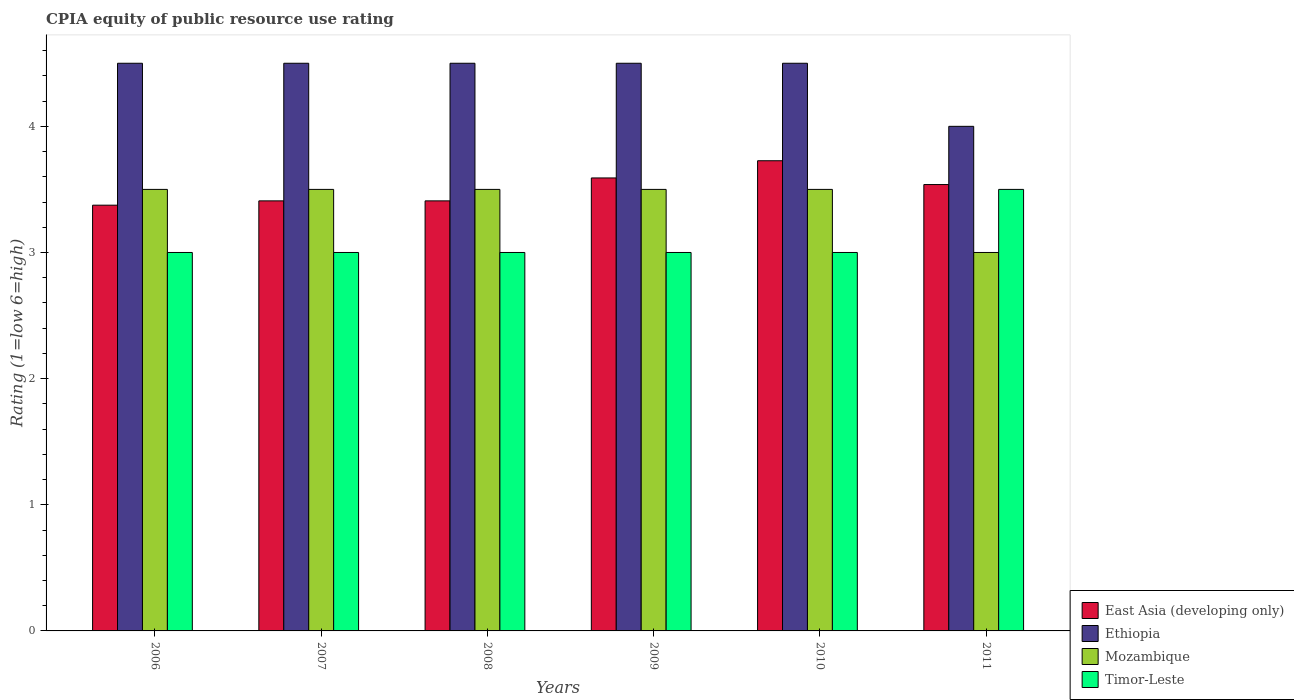How many bars are there on the 5th tick from the left?
Keep it short and to the point. 4. What is the CPIA rating in Mozambique in 2010?
Make the answer very short. 3.5. Across all years, what is the maximum CPIA rating in Ethiopia?
Your answer should be compact. 4.5. In which year was the CPIA rating in Mozambique maximum?
Ensure brevity in your answer.  2006. In which year was the CPIA rating in Mozambique minimum?
Ensure brevity in your answer.  2011. What is the total CPIA rating in East Asia (developing only) in the graph?
Keep it short and to the point. 21.05. What is the difference between the CPIA rating in East Asia (developing only) in 2010 and that in 2011?
Keep it short and to the point. 0.19. What is the average CPIA rating in Ethiopia per year?
Provide a succinct answer. 4.42. In the year 2011, what is the difference between the CPIA rating in East Asia (developing only) and CPIA rating in Timor-Leste?
Ensure brevity in your answer.  0.04. In how many years, is the CPIA rating in Mozambique greater than 2.4?
Provide a short and direct response. 6. Is the CPIA rating in Timor-Leste in 2007 less than that in 2011?
Keep it short and to the point. Yes. Is the difference between the CPIA rating in East Asia (developing only) in 2008 and 2011 greater than the difference between the CPIA rating in Timor-Leste in 2008 and 2011?
Your response must be concise. Yes. What is the difference between the highest and the lowest CPIA rating in Ethiopia?
Give a very brief answer. 0.5. In how many years, is the CPIA rating in Timor-Leste greater than the average CPIA rating in Timor-Leste taken over all years?
Your answer should be very brief. 1. Is the sum of the CPIA rating in Ethiopia in 2007 and 2008 greater than the maximum CPIA rating in Timor-Leste across all years?
Offer a terse response. Yes. Is it the case that in every year, the sum of the CPIA rating in East Asia (developing only) and CPIA rating in Ethiopia is greater than the sum of CPIA rating in Timor-Leste and CPIA rating in Mozambique?
Offer a terse response. Yes. What does the 4th bar from the left in 2011 represents?
Ensure brevity in your answer.  Timor-Leste. What does the 3rd bar from the right in 2011 represents?
Offer a terse response. Ethiopia. Is it the case that in every year, the sum of the CPIA rating in Ethiopia and CPIA rating in Mozambique is greater than the CPIA rating in Timor-Leste?
Provide a succinct answer. Yes. Are all the bars in the graph horizontal?
Your response must be concise. No. What is the difference between two consecutive major ticks on the Y-axis?
Your answer should be compact. 1. Does the graph contain grids?
Give a very brief answer. No. Where does the legend appear in the graph?
Offer a very short reply. Bottom right. How are the legend labels stacked?
Your answer should be compact. Vertical. What is the title of the graph?
Your answer should be very brief. CPIA equity of public resource use rating. What is the label or title of the X-axis?
Give a very brief answer. Years. What is the label or title of the Y-axis?
Provide a short and direct response. Rating (1=low 6=high). What is the Rating (1=low 6=high) of East Asia (developing only) in 2006?
Your response must be concise. 3.38. What is the Rating (1=low 6=high) of Ethiopia in 2006?
Provide a succinct answer. 4.5. What is the Rating (1=low 6=high) of Mozambique in 2006?
Your answer should be very brief. 3.5. What is the Rating (1=low 6=high) of East Asia (developing only) in 2007?
Ensure brevity in your answer.  3.41. What is the Rating (1=low 6=high) in Mozambique in 2007?
Offer a terse response. 3.5. What is the Rating (1=low 6=high) in East Asia (developing only) in 2008?
Provide a short and direct response. 3.41. What is the Rating (1=low 6=high) in Ethiopia in 2008?
Your answer should be very brief. 4.5. What is the Rating (1=low 6=high) of East Asia (developing only) in 2009?
Offer a terse response. 3.59. What is the Rating (1=low 6=high) of East Asia (developing only) in 2010?
Ensure brevity in your answer.  3.73. What is the Rating (1=low 6=high) in Mozambique in 2010?
Make the answer very short. 3.5. What is the Rating (1=low 6=high) of East Asia (developing only) in 2011?
Make the answer very short. 3.54. What is the Rating (1=low 6=high) of Timor-Leste in 2011?
Offer a terse response. 3.5. Across all years, what is the maximum Rating (1=low 6=high) in East Asia (developing only)?
Your answer should be compact. 3.73. Across all years, what is the minimum Rating (1=low 6=high) in East Asia (developing only)?
Your answer should be very brief. 3.38. Across all years, what is the minimum Rating (1=low 6=high) of Mozambique?
Provide a succinct answer. 3. Across all years, what is the minimum Rating (1=low 6=high) of Timor-Leste?
Give a very brief answer. 3. What is the total Rating (1=low 6=high) of East Asia (developing only) in the graph?
Offer a terse response. 21.05. What is the total Rating (1=low 6=high) of Timor-Leste in the graph?
Offer a terse response. 18.5. What is the difference between the Rating (1=low 6=high) in East Asia (developing only) in 2006 and that in 2007?
Offer a terse response. -0.03. What is the difference between the Rating (1=low 6=high) in Timor-Leste in 2006 and that in 2007?
Your answer should be very brief. 0. What is the difference between the Rating (1=low 6=high) of East Asia (developing only) in 2006 and that in 2008?
Provide a short and direct response. -0.03. What is the difference between the Rating (1=low 6=high) in Ethiopia in 2006 and that in 2008?
Your answer should be compact. 0. What is the difference between the Rating (1=low 6=high) of Mozambique in 2006 and that in 2008?
Your answer should be compact. 0. What is the difference between the Rating (1=low 6=high) in East Asia (developing only) in 2006 and that in 2009?
Give a very brief answer. -0.22. What is the difference between the Rating (1=low 6=high) in Ethiopia in 2006 and that in 2009?
Offer a terse response. 0. What is the difference between the Rating (1=low 6=high) of East Asia (developing only) in 2006 and that in 2010?
Make the answer very short. -0.35. What is the difference between the Rating (1=low 6=high) in Mozambique in 2006 and that in 2010?
Your response must be concise. 0. What is the difference between the Rating (1=low 6=high) of East Asia (developing only) in 2006 and that in 2011?
Make the answer very short. -0.16. What is the difference between the Rating (1=low 6=high) of Timor-Leste in 2006 and that in 2011?
Offer a terse response. -0.5. What is the difference between the Rating (1=low 6=high) in East Asia (developing only) in 2007 and that in 2008?
Provide a succinct answer. 0. What is the difference between the Rating (1=low 6=high) of Timor-Leste in 2007 and that in 2008?
Your answer should be compact. 0. What is the difference between the Rating (1=low 6=high) of East Asia (developing only) in 2007 and that in 2009?
Keep it short and to the point. -0.18. What is the difference between the Rating (1=low 6=high) in Ethiopia in 2007 and that in 2009?
Your answer should be very brief. 0. What is the difference between the Rating (1=low 6=high) in Timor-Leste in 2007 and that in 2009?
Ensure brevity in your answer.  0. What is the difference between the Rating (1=low 6=high) of East Asia (developing only) in 2007 and that in 2010?
Provide a succinct answer. -0.32. What is the difference between the Rating (1=low 6=high) of Mozambique in 2007 and that in 2010?
Your response must be concise. 0. What is the difference between the Rating (1=low 6=high) in East Asia (developing only) in 2007 and that in 2011?
Provide a succinct answer. -0.13. What is the difference between the Rating (1=low 6=high) in East Asia (developing only) in 2008 and that in 2009?
Keep it short and to the point. -0.18. What is the difference between the Rating (1=low 6=high) in Ethiopia in 2008 and that in 2009?
Your answer should be very brief. 0. What is the difference between the Rating (1=low 6=high) of Mozambique in 2008 and that in 2009?
Keep it short and to the point. 0. What is the difference between the Rating (1=low 6=high) of East Asia (developing only) in 2008 and that in 2010?
Ensure brevity in your answer.  -0.32. What is the difference between the Rating (1=low 6=high) in Ethiopia in 2008 and that in 2010?
Your response must be concise. 0. What is the difference between the Rating (1=low 6=high) in Mozambique in 2008 and that in 2010?
Provide a succinct answer. 0. What is the difference between the Rating (1=low 6=high) of East Asia (developing only) in 2008 and that in 2011?
Your answer should be very brief. -0.13. What is the difference between the Rating (1=low 6=high) in Timor-Leste in 2008 and that in 2011?
Your answer should be compact. -0.5. What is the difference between the Rating (1=low 6=high) in East Asia (developing only) in 2009 and that in 2010?
Give a very brief answer. -0.14. What is the difference between the Rating (1=low 6=high) of East Asia (developing only) in 2009 and that in 2011?
Offer a terse response. 0.05. What is the difference between the Rating (1=low 6=high) of Ethiopia in 2009 and that in 2011?
Give a very brief answer. 0.5. What is the difference between the Rating (1=low 6=high) of Timor-Leste in 2009 and that in 2011?
Keep it short and to the point. -0.5. What is the difference between the Rating (1=low 6=high) in East Asia (developing only) in 2010 and that in 2011?
Offer a very short reply. 0.19. What is the difference between the Rating (1=low 6=high) of Ethiopia in 2010 and that in 2011?
Your answer should be compact. 0.5. What is the difference between the Rating (1=low 6=high) of Mozambique in 2010 and that in 2011?
Your answer should be compact. 0.5. What is the difference between the Rating (1=low 6=high) of Timor-Leste in 2010 and that in 2011?
Give a very brief answer. -0.5. What is the difference between the Rating (1=low 6=high) in East Asia (developing only) in 2006 and the Rating (1=low 6=high) in Ethiopia in 2007?
Your answer should be very brief. -1.12. What is the difference between the Rating (1=low 6=high) in East Asia (developing only) in 2006 and the Rating (1=low 6=high) in Mozambique in 2007?
Your answer should be very brief. -0.12. What is the difference between the Rating (1=low 6=high) of East Asia (developing only) in 2006 and the Rating (1=low 6=high) of Timor-Leste in 2007?
Offer a terse response. 0.38. What is the difference between the Rating (1=low 6=high) of Ethiopia in 2006 and the Rating (1=low 6=high) of Mozambique in 2007?
Offer a terse response. 1. What is the difference between the Rating (1=low 6=high) in Ethiopia in 2006 and the Rating (1=low 6=high) in Timor-Leste in 2007?
Offer a very short reply. 1.5. What is the difference between the Rating (1=low 6=high) of Mozambique in 2006 and the Rating (1=low 6=high) of Timor-Leste in 2007?
Offer a very short reply. 0.5. What is the difference between the Rating (1=low 6=high) of East Asia (developing only) in 2006 and the Rating (1=low 6=high) of Ethiopia in 2008?
Your answer should be compact. -1.12. What is the difference between the Rating (1=low 6=high) in East Asia (developing only) in 2006 and the Rating (1=low 6=high) in Mozambique in 2008?
Offer a terse response. -0.12. What is the difference between the Rating (1=low 6=high) in Ethiopia in 2006 and the Rating (1=low 6=high) in Mozambique in 2008?
Your answer should be very brief. 1. What is the difference between the Rating (1=low 6=high) in Mozambique in 2006 and the Rating (1=low 6=high) in Timor-Leste in 2008?
Give a very brief answer. 0.5. What is the difference between the Rating (1=low 6=high) of East Asia (developing only) in 2006 and the Rating (1=low 6=high) of Ethiopia in 2009?
Your answer should be very brief. -1.12. What is the difference between the Rating (1=low 6=high) of East Asia (developing only) in 2006 and the Rating (1=low 6=high) of Mozambique in 2009?
Your answer should be compact. -0.12. What is the difference between the Rating (1=low 6=high) of East Asia (developing only) in 2006 and the Rating (1=low 6=high) of Ethiopia in 2010?
Provide a short and direct response. -1.12. What is the difference between the Rating (1=low 6=high) of East Asia (developing only) in 2006 and the Rating (1=low 6=high) of Mozambique in 2010?
Make the answer very short. -0.12. What is the difference between the Rating (1=low 6=high) of Ethiopia in 2006 and the Rating (1=low 6=high) of Mozambique in 2010?
Give a very brief answer. 1. What is the difference between the Rating (1=low 6=high) of Ethiopia in 2006 and the Rating (1=low 6=high) of Timor-Leste in 2010?
Provide a short and direct response. 1.5. What is the difference between the Rating (1=low 6=high) of East Asia (developing only) in 2006 and the Rating (1=low 6=high) of Ethiopia in 2011?
Offer a very short reply. -0.62. What is the difference between the Rating (1=low 6=high) of East Asia (developing only) in 2006 and the Rating (1=low 6=high) of Mozambique in 2011?
Your answer should be compact. 0.38. What is the difference between the Rating (1=low 6=high) of East Asia (developing only) in 2006 and the Rating (1=low 6=high) of Timor-Leste in 2011?
Your answer should be compact. -0.12. What is the difference between the Rating (1=low 6=high) of Mozambique in 2006 and the Rating (1=low 6=high) of Timor-Leste in 2011?
Your response must be concise. 0. What is the difference between the Rating (1=low 6=high) of East Asia (developing only) in 2007 and the Rating (1=low 6=high) of Ethiopia in 2008?
Keep it short and to the point. -1.09. What is the difference between the Rating (1=low 6=high) of East Asia (developing only) in 2007 and the Rating (1=low 6=high) of Mozambique in 2008?
Give a very brief answer. -0.09. What is the difference between the Rating (1=low 6=high) of East Asia (developing only) in 2007 and the Rating (1=low 6=high) of Timor-Leste in 2008?
Ensure brevity in your answer.  0.41. What is the difference between the Rating (1=low 6=high) of Ethiopia in 2007 and the Rating (1=low 6=high) of Mozambique in 2008?
Offer a very short reply. 1. What is the difference between the Rating (1=low 6=high) of Ethiopia in 2007 and the Rating (1=low 6=high) of Timor-Leste in 2008?
Provide a short and direct response. 1.5. What is the difference between the Rating (1=low 6=high) of Mozambique in 2007 and the Rating (1=low 6=high) of Timor-Leste in 2008?
Your answer should be very brief. 0.5. What is the difference between the Rating (1=low 6=high) in East Asia (developing only) in 2007 and the Rating (1=low 6=high) in Ethiopia in 2009?
Your response must be concise. -1.09. What is the difference between the Rating (1=low 6=high) in East Asia (developing only) in 2007 and the Rating (1=low 6=high) in Mozambique in 2009?
Your answer should be compact. -0.09. What is the difference between the Rating (1=low 6=high) in East Asia (developing only) in 2007 and the Rating (1=low 6=high) in Timor-Leste in 2009?
Make the answer very short. 0.41. What is the difference between the Rating (1=low 6=high) in Ethiopia in 2007 and the Rating (1=low 6=high) in Mozambique in 2009?
Offer a terse response. 1. What is the difference between the Rating (1=low 6=high) of East Asia (developing only) in 2007 and the Rating (1=low 6=high) of Ethiopia in 2010?
Your answer should be very brief. -1.09. What is the difference between the Rating (1=low 6=high) of East Asia (developing only) in 2007 and the Rating (1=low 6=high) of Mozambique in 2010?
Provide a short and direct response. -0.09. What is the difference between the Rating (1=low 6=high) in East Asia (developing only) in 2007 and the Rating (1=low 6=high) in Timor-Leste in 2010?
Offer a very short reply. 0.41. What is the difference between the Rating (1=low 6=high) in Ethiopia in 2007 and the Rating (1=low 6=high) in Mozambique in 2010?
Give a very brief answer. 1. What is the difference between the Rating (1=low 6=high) of Ethiopia in 2007 and the Rating (1=low 6=high) of Timor-Leste in 2010?
Your response must be concise. 1.5. What is the difference between the Rating (1=low 6=high) of East Asia (developing only) in 2007 and the Rating (1=low 6=high) of Ethiopia in 2011?
Give a very brief answer. -0.59. What is the difference between the Rating (1=low 6=high) in East Asia (developing only) in 2007 and the Rating (1=low 6=high) in Mozambique in 2011?
Provide a succinct answer. 0.41. What is the difference between the Rating (1=low 6=high) in East Asia (developing only) in 2007 and the Rating (1=low 6=high) in Timor-Leste in 2011?
Your response must be concise. -0.09. What is the difference between the Rating (1=low 6=high) of Ethiopia in 2007 and the Rating (1=low 6=high) of Timor-Leste in 2011?
Your response must be concise. 1. What is the difference between the Rating (1=low 6=high) in East Asia (developing only) in 2008 and the Rating (1=low 6=high) in Ethiopia in 2009?
Provide a succinct answer. -1.09. What is the difference between the Rating (1=low 6=high) of East Asia (developing only) in 2008 and the Rating (1=low 6=high) of Mozambique in 2009?
Your answer should be compact. -0.09. What is the difference between the Rating (1=low 6=high) of East Asia (developing only) in 2008 and the Rating (1=low 6=high) of Timor-Leste in 2009?
Make the answer very short. 0.41. What is the difference between the Rating (1=low 6=high) of Ethiopia in 2008 and the Rating (1=low 6=high) of Timor-Leste in 2009?
Provide a succinct answer. 1.5. What is the difference between the Rating (1=low 6=high) in Mozambique in 2008 and the Rating (1=low 6=high) in Timor-Leste in 2009?
Your response must be concise. 0.5. What is the difference between the Rating (1=low 6=high) in East Asia (developing only) in 2008 and the Rating (1=low 6=high) in Ethiopia in 2010?
Your answer should be very brief. -1.09. What is the difference between the Rating (1=low 6=high) of East Asia (developing only) in 2008 and the Rating (1=low 6=high) of Mozambique in 2010?
Your answer should be compact. -0.09. What is the difference between the Rating (1=low 6=high) of East Asia (developing only) in 2008 and the Rating (1=low 6=high) of Timor-Leste in 2010?
Provide a succinct answer. 0.41. What is the difference between the Rating (1=low 6=high) in Mozambique in 2008 and the Rating (1=low 6=high) in Timor-Leste in 2010?
Offer a terse response. 0.5. What is the difference between the Rating (1=low 6=high) in East Asia (developing only) in 2008 and the Rating (1=low 6=high) in Ethiopia in 2011?
Your answer should be very brief. -0.59. What is the difference between the Rating (1=low 6=high) in East Asia (developing only) in 2008 and the Rating (1=low 6=high) in Mozambique in 2011?
Your response must be concise. 0.41. What is the difference between the Rating (1=low 6=high) of East Asia (developing only) in 2008 and the Rating (1=low 6=high) of Timor-Leste in 2011?
Your response must be concise. -0.09. What is the difference between the Rating (1=low 6=high) in Ethiopia in 2008 and the Rating (1=low 6=high) in Mozambique in 2011?
Your answer should be compact. 1.5. What is the difference between the Rating (1=low 6=high) in East Asia (developing only) in 2009 and the Rating (1=low 6=high) in Ethiopia in 2010?
Your answer should be compact. -0.91. What is the difference between the Rating (1=low 6=high) in East Asia (developing only) in 2009 and the Rating (1=low 6=high) in Mozambique in 2010?
Give a very brief answer. 0.09. What is the difference between the Rating (1=low 6=high) of East Asia (developing only) in 2009 and the Rating (1=low 6=high) of Timor-Leste in 2010?
Give a very brief answer. 0.59. What is the difference between the Rating (1=low 6=high) in Ethiopia in 2009 and the Rating (1=low 6=high) in Mozambique in 2010?
Your answer should be very brief. 1. What is the difference between the Rating (1=low 6=high) in Mozambique in 2009 and the Rating (1=low 6=high) in Timor-Leste in 2010?
Provide a succinct answer. 0.5. What is the difference between the Rating (1=low 6=high) of East Asia (developing only) in 2009 and the Rating (1=low 6=high) of Ethiopia in 2011?
Keep it short and to the point. -0.41. What is the difference between the Rating (1=low 6=high) of East Asia (developing only) in 2009 and the Rating (1=low 6=high) of Mozambique in 2011?
Ensure brevity in your answer.  0.59. What is the difference between the Rating (1=low 6=high) of East Asia (developing only) in 2009 and the Rating (1=low 6=high) of Timor-Leste in 2011?
Provide a short and direct response. 0.09. What is the difference between the Rating (1=low 6=high) in Ethiopia in 2009 and the Rating (1=low 6=high) in Timor-Leste in 2011?
Ensure brevity in your answer.  1. What is the difference between the Rating (1=low 6=high) in East Asia (developing only) in 2010 and the Rating (1=low 6=high) in Ethiopia in 2011?
Your answer should be very brief. -0.27. What is the difference between the Rating (1=low 6=high) in East Asia (developing only) in 2010 and the Rating (1=low 6=high) in Mozambique in 2011?
Make the answer very short. 0.73. What is the difference between the Rating (1=low 6=high) of East Asia (developing only) in 2010 and the Rating (1=low 6=high) of Timor-Leste in 2011?
Keep it short and to the point. 0.23. What is the difference between the Rating (1=low 6=high) in Ethiopia in 2010 and the Rating (1=low 6=high) in Mozambique in 2011?
Give a very brief answer. 1.5. What is the difference between the Rating (1=low 6=high) of Ethiopia in 2010 and the Rating (1=low 6=high) of Timor-Leste in 2011?
Offer a very short reply. 1. What is the difference between the Rating (1=low 6=high) of Mozambique in 2010 and the Rating (1=low 6=high) of Timor-Leste in 2011?
Offer a very short reply. 0. What is the average Rating (1=low 6=high) in East Asia (developing only) per year?
Provide a succinct answer. 3.51. What is the average Rating (1=low 6=high) of Ethiopia per year?
Offer a very short reply. 4.42. What is the average Rating (1=low 6=high) of Mozambique per year?
Make the answer very short. 3.42. What is the average Rating (1=low 6=high) in Timor-Leste per year?
Offer a terse response. 3.08. In the year 2006, what is the difference between the Rating (1=low 6=high) of East Asia (developing only) and Rating (1=low 6=high) of Ethiopia?
Give a very brief answer. -1.12. In the year 2006, what is the difference between the Rating (1=low 6=high) of East Asia (developing only) and Rating (1=low 6=high) of Mozambique?
Provide a short and direct response. -0.12. In the year 2006, what is the difference between the Rating (1=low 6=high) of Ethiopia and Rating (1=low 6=high) of Mozambique?
Your response must be concise. 1. In the year 2006, what is the difference between the Rating (1=low 6=high) of Mozambique and Rating (1=low 6=high) of Timor-Leste?
Offer a very short reply. 0.5. In the year 2007, what is the difference between the Rating (1=low 6=high) in East Asia (developing only) and Rating (1=low 6=high) in Ethiopia?
Your answer should be very brief. -1.09. In the year 2007, what is the difference between the Rating (1=low 6=high) in East Asia (developing only) and Rating (1=low 6=high) in Mozambique?
Your response must be concise. -0.09. In the year 2007, what is the difference between the Rating (1=low 6=high) of East Asia (developing only) and Rating (1=low 6=high) of Timor-Leste?
Give a very brief answer. 0.41. In the year 2007, what is the difference between the Rating (1=low 6=high) of Mozambique and Rating (1=low 6=high) of Timor-Leste?
Provide a succinct answer. 0.5. In the year 2008, what is the difference between the Rating (1=low 6=high) of East Asia (developing only) and Rating (1=low 6=high) of Ethiopia?
Your answer should be very brief. -1.09. In the year 2008, what is the difference between the Rating (1=low 6=high) of East Asia (developing only) and Rating (1=low 6=high) of Mozambique?
Provide a short and direct response. -0.09. In the year 2008, what is the difference between the Rating (1=low 6=high) in East Asia (developing only) and Rating (1=low 6=high) in Timor-Leste?
Offer a terse response. 0.41. In the year 2009, what is the difference between the Rating (1=low 6=high) of East Asia (developing only) and Rating (1=low 6=high) of Ethiopia?
Provide a short and direct response. -0.91. In the year 2009, what is the difference between the Rating (1=low 6=high) in East Asia (developing only) and Rating (1=low 6=high) in Mozambique?
Provide a short and direct response. 0.09. In the year 2009, what is the difference between the Rating (1=low 6=high) in East Asia (developing only) and Rating (1=low 6=high) in Timor-Leste?
Provide a succinct answer. 0.59. In the year 2009, what is the difference between the Rating (1=low 6=high) in Ethiopia and Rating (1=low 6=high) in Mozambique?
Ensure brevity in your answer.  1. In the year 2010, what is the difference between the Rating (1=low 6=high) of East Asia (developing only) and Rating (1=low 6=high) of Ethiopia?
Keep it short and to the point. -0.77. In the year 2010, what is the difference between the Rating (1=low 6=high) in East Asia (developing only) and Rating (1=low 6=high) in Mozambique?
Make the answer very short. 0.23. In the year 2010, what is the difference between the Rating (1=low 6=high) of East Asia (developing only) and Rating (1=low 6=high) of Timor-Leste?
Provide a short and direct response. 0.73. In the year 2010, what is the difference between the Rating (1=low 6=high) of Ethiopia and Rating (1=low 6=high) of Mozambique?
Your response must be concise. 1. In the year 2011, what is the difference between the Rating (1=low 6=high) in East Asia (developing only) and Rating (1=low 6=high) in Ethiopia?
Make the answer very short. -0.46. In the year 2011, what is the difference between the Rating (1=low 6=high) in East Asia (developing only) and Rating (1=low 6=high) in Mozambique?
Ensure brevity in your answer.  0.54. In the year 2011, what is the difference between the Rating (1=low 6=high) in East Asia (developing only) and Rating (1=low 6=high) in Timor-Leste?
Provide a short and direct response. 0.04. What is the ratio of the Rating (1=low 6=high) of East Asia (developing only) in 2006 to that in 2007?
Keep it short and to the point. 0.99. What is the ratio of the Rating (1=low 6=high) of Mozambique in 2006 to that in 2007?
Give a very brief answer. 1. What is the ratio of the Rating (1=low 6=high) of Ethiopia in 2006 to that in 2008?
Your response must be concise. 1. What is the ratio of the Rating (1=low 6=high) of Timor-Leste in 2006 to that in 2008?
Offer a terse response. 1. What is the ratio of the Rating (1=low 6=high) in East Asia (developing only) in 2006 to that in 2009?
Offer a very short reply. 0.94. What is the ratio of the Rating (1=low 6=high) of Ethiopia in 2006 to that in 2009?
Keep it short and to the point. 1. What is the ratio of the Rating (1=low 6=high) of Mozambique in 2006 to that in 2009?
Make the answer very short. 1. What is the ratio of the Rating (1=low 6=high) of East Asia (developing only) in 2006 to that in 2010?
Your answer should be compact. 0.91. What is the ratio of the Rating (1=low 6=high) of Mozambique in 2006 to that in 2010?
Offer a terse response. 1. What is the ratio of the Rating (1=low 6=high) of East Asia (developing only) in 2006 to that in 2011?
Provide a short and direct response. 0.95. What is the ratio of the Rating (1=low 6=high) of Ethiopia in 2006 to that in 2011?
Keep it short and to the point. 1.12. What is the ratio of the Rating (1=low 6=high) in Ethiopia in 2007 to that in 2008?
Make the answer very short. 1. What is the ratio of the Rating (1=low 6=high) in Timor-Leste in 2007 to that in 2008?
Offer a terse response. 1. What is the ratio of the Rating (1=low 6=high) in East Asia (developing only) in 2007 to that in 2009?
Provide a succinct answer. 0.95. What is the ratio of the Rating (1=low 6=high) in Ethiopia in 2007 to that in 2009?
Your answer should be very brief. 1. What is the ratio of the Rating (1=low 6=high) of Mozambique in 2007 to that in 2009?
Your response must be concise. 1. What is the ratio of the Rating (1=low 6=high) of Timor-Leste in 2007 to that in 2009?
Provide a short and direct response. 1. What is the ratio of the Rating (1=low 6=high) of East Asia (developing only) in 2007 to that in 2010?
Offer a very short reply. 0.91. What is the ratio of the Rating (1=low 6=high) in Ethiopia in 2007 to that in 2010?
Provide a succinct answer. 1. What is the ratio of the Rating (1=low 6=high) of Mozambique in 2007 to that in 2010?
Provide a short and direct response. 1. What is the ratio of the Rating (1=low 6=high) in Timor-Leste in 2007 to that in 2010?
Your answer should be very brief. 1. What is the ratio of the Rating (1=low 6=high) in East Asia (developing only) in 2007 to that in 2011?
Keep it short and to the point. 0.96. What is the ratio of the Rating (1=low 6=high) in Mozambique in 2007 to that in 2011?
Your answer should be very brief. 1.17. What is the ratio of the Rating (1=low 6=high) in East Asia (developing only) in 2008 to that in 2009?
Offer a very short reply. 0.95. What is the ratio of the Rating (1=low 6=high) in East Asia (developing only) in 2008 to that in 2010?
Provide a succinct answer. 0.91. What is the ratio of the Rating (1=low 6=high) in Ethiopia in 2008 to that in 2010?
Provide a short and direct response. 1. What is the ratio of the Rating (1=low 6=high) of Mozambique in 2008 to that in 2010?
Provide a succinct answer. 1. What is the ratio of the Rating (1=low 6=high) of East Asia (developing only) in 2008 to that in 2011?
Offer a terse response. 0.96. What is the ratio of the Rating (1=low 6=high) of Mozambique in 2008 to that in 2011?
Your answer should be very brief. 1.17. What is the ratio of the Rating (1=low 6=high) in East Asia (developing only) in 2009 to that in 2010?
Provide a succinct answer. 0.96. What is the ratio of the Rating (1=low 6=high) in Ethiopia in 2009 to that in 2010?
Your answer should be compact. 1. What is the ratio of the Rating (1=low 6=high) in Mozambique in 2009 to that in 2010?
Make the answer very short. 1. What is the ratio of the Rating (1=low 6=high) of East Asia (developing only) in 2009 to that in 2011?
Your answer should be very brief. 1.01. What is the ratio of the Rating (1=low 6=high) of Mozambique in 2009 to that in 2011?
Offer a very short reply. 1.17. What is the ratio of the Rating (1=low 6=high) of East Asia (developing only) in 2010 to that in 2011?
Provide a short and direct response. 1.05. What is the ratio of the Rating (1=low 6=high) in Mozambique in 2010 to that in 2011?
Your answer should be very brief. 1.17. What is the difference between the highest and the second highest Rating (1=low 6=high) in East Asia (developing only)?
Your answer should be compact. 0.14. What is the difference between the highest and the lowest Rating (1=low 6=high) in East Asia (developing only)?
Give a very brief answer. 0.35. What is the difference between the highest and the lowest Rating (1=low 6=high) in Timor-Leste?
Provide a short and direct response. 0.5. 